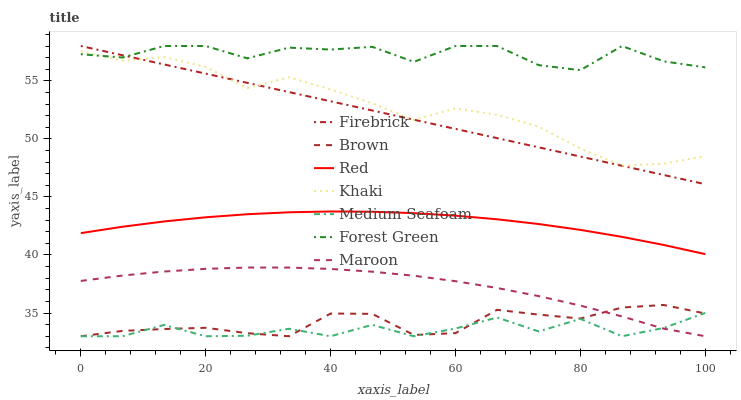Does Medium Seafoam have the minimum area under the curve?
Answer yes or no. Yes. Does Forest Green have the maximum area under the curve?
Answer yes or no. Yes. Does Khaki have the minimum area under the curve?
Answer yes or no. No. Does Khaki have the maximum area under the curve?
Answer yes or no. No. Is Firebrick the smoothest?
Answer yes or no. Yes. Is Forest Green the roughest?
Answer yes or no. Yes. Is Khaki the smoothest?
Answer yes or no. No. Is Khaki the roughest?
Answer yes or no. No. Does Brown have the lowest value?
Answer yes or no. Yes. Does Khaki have the lowest value?
Answer yes or no. No. Does Forest Green have the highest value?
Answer yes or no. Yes. Does Khaki have the highest value?
Answer yes or no. No. Is Red less than Forest Green?
Answer yes or no. Yes. Is Forest Green greater than Brown?
Answer yes or no. Yes. Does Khaki intersect Forest Green?
Answer yes or no. Yes. Is Khaki less than Forest Green?
Answer yes or no. No. Is Khaki greater than Forest Green?
Answer yes or no. No. Does Red intersect Forest Green?
Answer yes or no. No. 